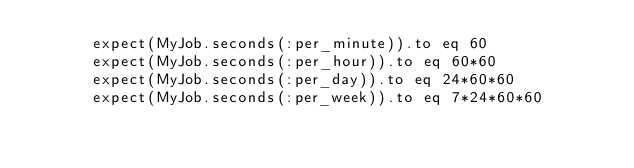<code> <loc_0><loc_0><loc_500><loc_500><_Ruby_>      expect(MyJob.seconds(:per_minute)).to eq 60
      expect(MyJob.seconds(:per_hour)).to eq 60*60
      expect(MyJob.seconds(:per_day)).to eq 24*60*60
      expect(MyJob.seconds(:per_week)).to eq 7*24*60*60</code> 